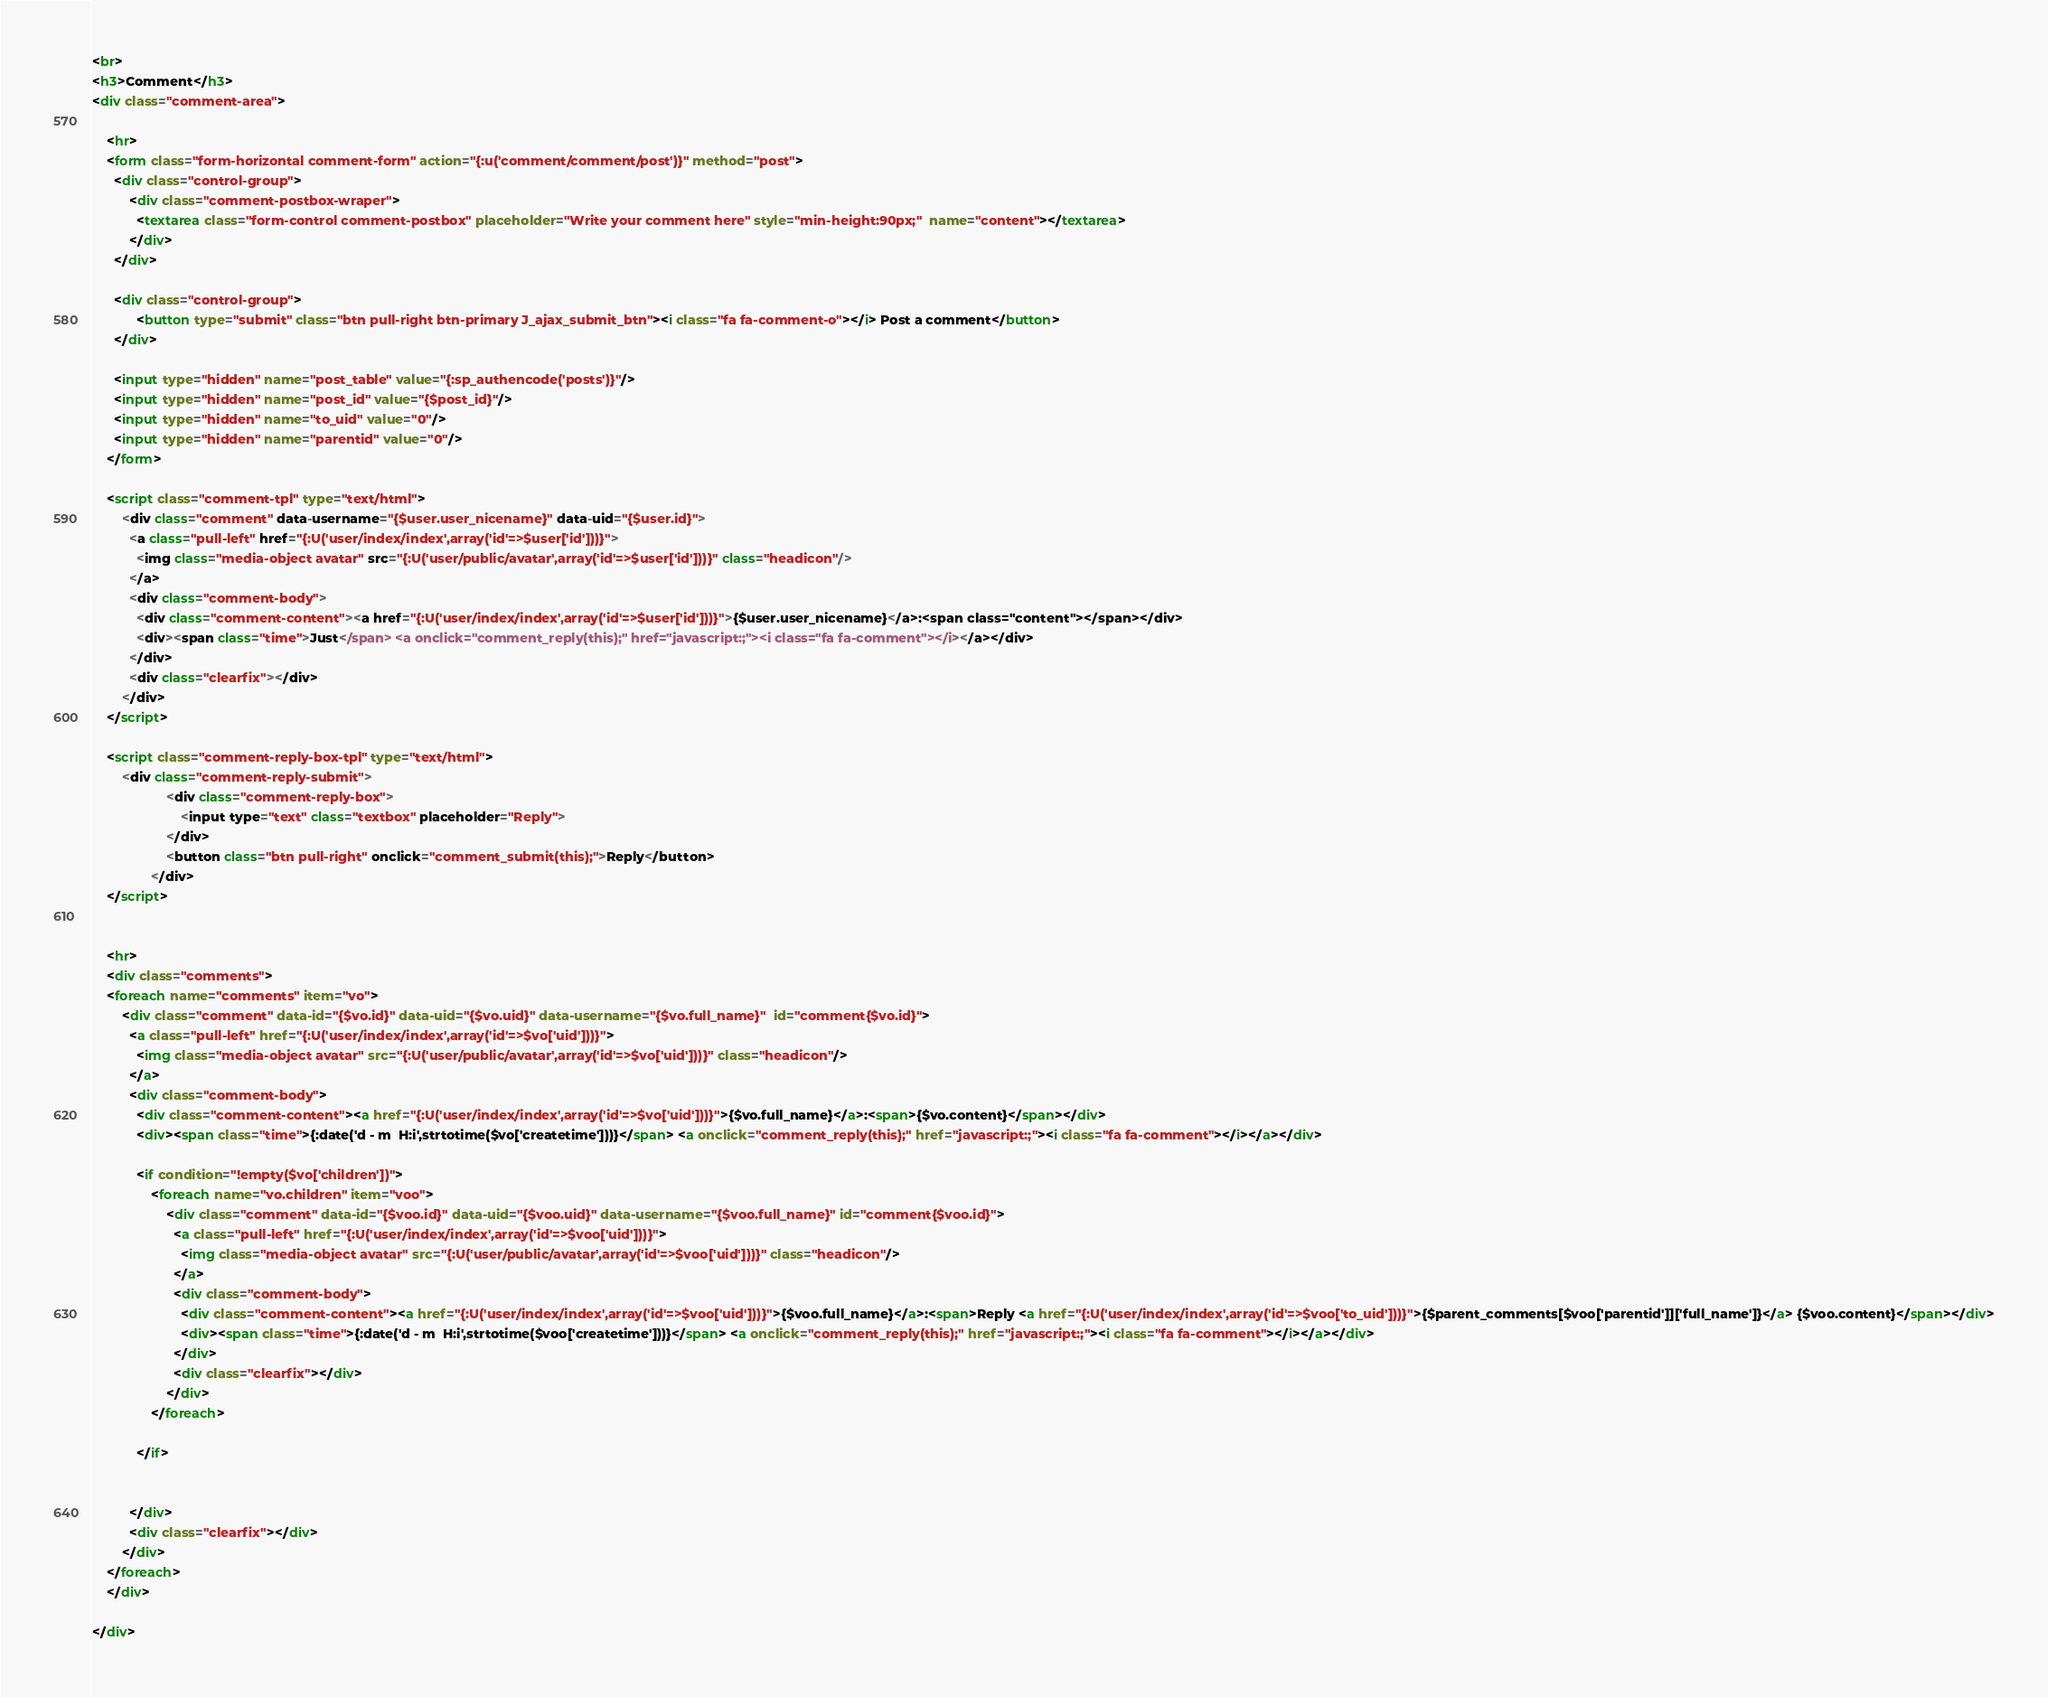<code> <loc_0><loc_0><loc_500><loc_500><_HTML_><br>
<h3>Comment</h3>
<div class="comment-area">

	<hr>
	<form class="form-horizontal comment-form" action="{:u('comment/comment/post')}" method="post">
	  <div class="control-group">
		  <div class="comment-postbox-wraper">
		  	<textarea class="form-control comment-postbox" placeholder="Write your comment here" style="min-height:90px;"  name="content"></textarea>
		  </div>
	  </div>
	  
	  <div class="control-group">
	   		<button type="submit" class="btn pull-right btn-primary J_ajax_submit_btn"><i class="fa fa-comment-o"></i> Post a comment</button>
	  </div>
	  
	  <input type="hidden" name="post_table" value="{:sp_authencode('posts')}"/>
	  <input type="hidden" name="post_id" value="{$post_id}"/>
	  <input type="hidden" name="to_uid" value="0"/>
	  <input type="hidden" name="parentid" value="0"/>
	</form>
	
	<script class="comment-tpl" type="text/html">
		<div class="comment" data-username="{$user.user_nicename}" data-uid="{$user.id}">
		  <a class="pull-left" href="{:U('user/index/index',array('id'=>$user['id']))}">
		    <img class="media-object avatar" src="{:U('user/public/avatar',array('id'=>$user['id']))}" class="headicon"/>
		  </a>
		  <div class="comment-body">
		    <div class="comment-content"><a href="{:U('user/index/index',array('id'=>$user['id']))}">{$user.user_nicename}</a>:<span class="content"></span></div>
		    <div><span class="time">Just</span> <a onclick="comment_reply(this);" href="javascript:;"><i class="fa fa-comment"></i></a></div>
		  </div>
		  <div class="clearfix"></div>
		</div>
	</script>
	
	<script class="comment-reply-box-tpl" type="text/html">
		<div class="comment-reply-submit">
                    <div class="comment-reply-box">
                        <input type="text" class="textbox" placeholder="Reply">
                    </div>
                    <button class="btn pull-right" onclick="comment_submit(this);">Reply</button>
                </div>
	</script>
	
	
	<hr>
	<div class="comments">
	<foreach name="comments" item="vo">
	 	<div class="comment" data-id="{$vo.id}" data-uid="{$vo.uid}" data-username="{$vo.full_name}"  id="comment{$vo.id}">
		  <a class="pull-left" href="{:U('user/index/index',array('id'=>$vo['uid']))}">
		    <img class="media-object avatar" src="{:U('user/public/avatar',array('id'=>$vo['uid']))}" class="headicon"/>
		  </a>
		  <div class="comment-body">
		    <div class="comment-content"><a href="{:U('user/index/index',array('id'=>$vo['uid']))}">{$vo.full_name}</a>:<span>{$vo.content}</span></div>
		    <div><span class="time">{:date('d - m  H:i',strtotime($vo['createtime']))}</span> <a onclick="comment_reply(this);" href="javascript:;"><i class="fa fa-comment"></i></a></div>
		    
		    <if condition="!empty($vo['children'])">
		    	<foreach name="vo.children" item="voo">
			    	<div class="comment" data-id="{$voo.id}" data-uid="{$voo.uid}" data-username="{$voo.full_name}" id="comment{$voo.id}">
					  <a class="pull-left" href="{:U('user/index/index',array('id'=>$voo['uid']))}">
					    <img class="media-object avatar" src="{:U('user/public/avatar',array('id'=>$voo['uid']))}" class="headicon"/>
					  </a>
					  <div class="comment-body">
					    <div class="comment-content"><a href="{:U('user/index/index',array('id'=>$voo['uid']))}">{$voo.full_name}</a>:<span>Reply <a href="{:U('user/index/index',array('id'=>$voo['to_uid']))}">{$parent_comments[$voo['parentid']]['full_name']}</a> {$voo.content}</span></div>
					    <div><span class="time">{:date('d - m  H:i',strtotime($voo['createtime']))}</span> <a onclick="comment_reply(this);" href="javascript:;"><i class="fa fa-comment"></i></a></div>
					  </div>
					  <div class="clearfix"></div>
					</div>
		    	</foreach>
		    
		    </if>
		    
		    
		  </div>
		  <div class="clearfix"></div>
		</div>
	</foreach>
	</div>
	
</div>

</code> 